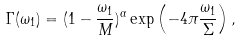<formula> <loc_0><loc_0><loc_500><loc_500>\Gamma ( \omega _ { 1 } ) = ( 1 - \frac { \omega _ { 1 } } { M } ) ^ { \alpha } \exp \left ( - 4 \pi \frac { \omega _ { 1 } } { \Sigma } \right ) ,</formula> 